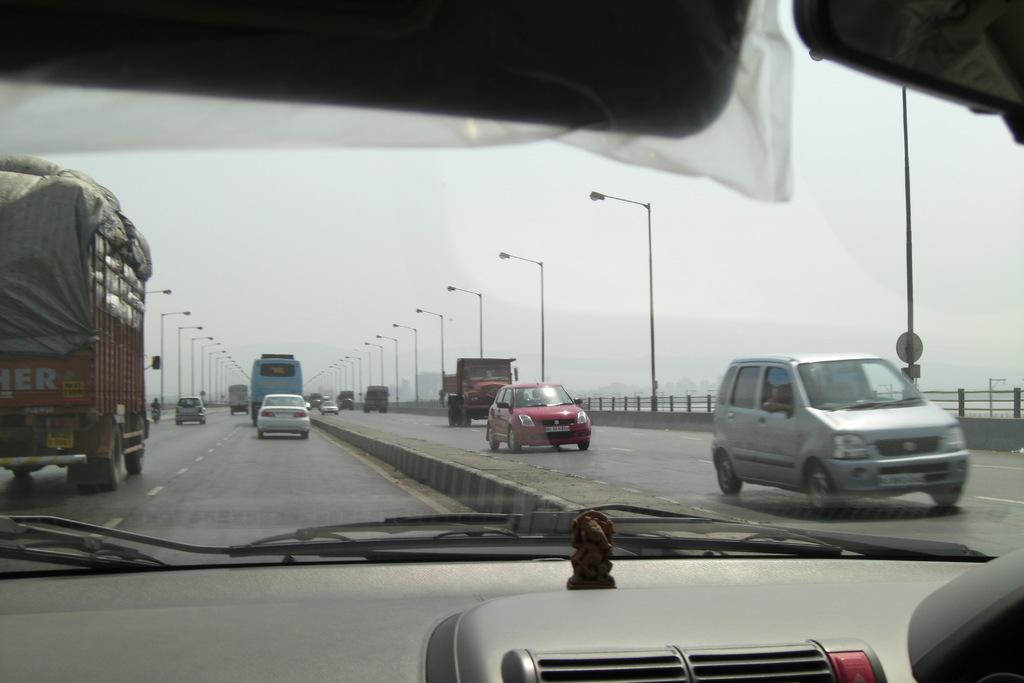What can be seen on the road in the image? There are vehicles parked on the road in the image. Can you describe the unique feature of the car in the foreground? There is a statue inside a car in the foreground. What is visible in the background of the image? There is a group of poles and the sky in the background. What type of comfort does the grandmother provide to the parent in the image? There is no parent or grandmother present in the image; it features vehicles, a car with a statue, poles, and the sky. 